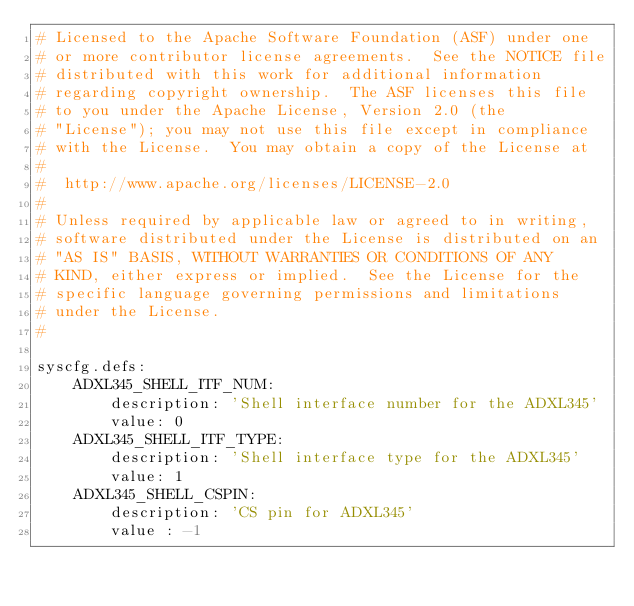<code> <loc_0><loc_0><loc_500><loc_500><_YAML_># Licensed to the Apache Software Foundation (ASF) under one
# or more contributor license agreements.  See the NOTICE file
# distributed with this work for additional information
# regarding copyright ownership.  The ASF licenses this file
# to you under the Apache License, Version 2.0 (the
# "License"); you may not use this file except in compliance
# with the License.  You may obtain a copy of the License at
#
#  http://www.apache.org/licenses/LICENSE-2.0
#
# Unless required by applicable law or agreed to in writing,
# software distributed under the License is distributed on an
# "AS IS" BASIS, WITHOUT WARRANTIES OR CONDITIONS OF ANY
# KIND, either express or implied.  See the License for the
# specific language governing permissions and limitations
# under the License.
#

syscfg.defs:
    ADXL345_SHELL_ITF_NUM:
        description: 'Shell interface number for the ADXL345'
        value: 0
    ADXL345_SHELL_ITF_TYPE:
        description: 'Shell interface type for the ADXL345'
        value: 1
    ADXL345_SHELL_CSPIN:
        description: 'CS pin for ADXL345'
        value : -1</code> 